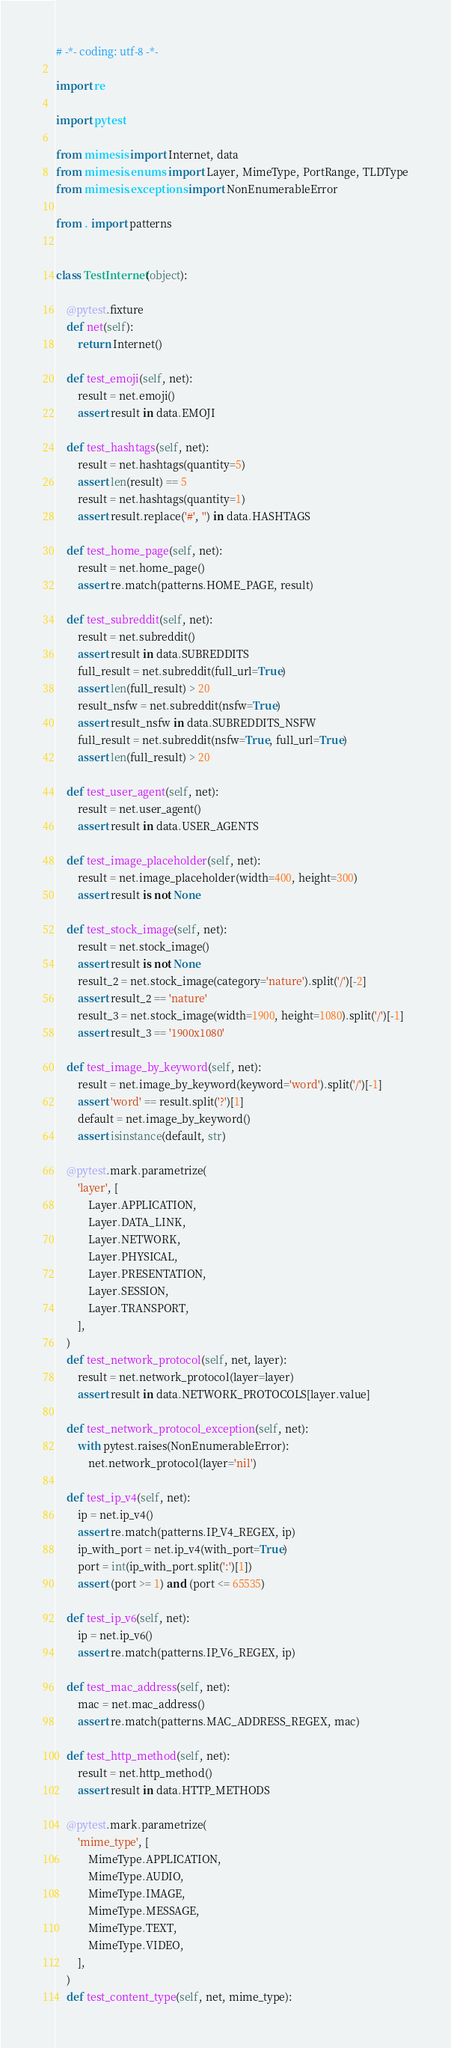<code> <loc_0><loc_0><loc_500><loc_500><_Python_># -*- coding: utf-8 -*-

import re

import pytest

from mimesis import Internet, data
from mimesis.enums import Layer, MimeType, PortRange, TLDType
from mimesis.exceptions import NonEnumerableError

from . import patterns


class TestInternet(object):

    @pytest.fixture
    def net(self):
        return Internet()

    def test_emoji(self, net):
        result = net.emoji()
        assert result in data.EMOJI

    def test_hashtags(self, net):
        result = net.hashtags(quantity=5)
        assert len(result) == 5
        result = net.hashtags(quantity=1)
        assert result.replace('#', '') in data.HASHTAGS

    def test_home_page(self, net):
        result = net.home_page()
        assert re.match(patterns.HOME_PAGE, result)

    def test_subreddit(self, net):
        result = net.subreddit()
        assert result in data.SUBREDDITS
        full_result = net.subreddit(full_url=True)
        assert len(full_result) > 20
        result_nsfw = net.subreddit(nsfw=True)
        assert result_nsfw in data.SUBREDDITS_NSFW
        full_result = net.subreddit(nsfw=True, full_url=True)
        assert len(full_result) > 20

    def test_user_agent(self, net):
        result = net.user_agent()
        assert result in data.USER_AGENTS

    def test_image_placeholder(self, net):
        result = net.image_placeholder(width=400, height=300)
        assert result is not None

    def test_stock_image(self, net):
        result = net.stock_image()
        assert result is not None
        result_2 = net.stock_image(category='nature').split('/')[-2]
        assert result_2 == 'nature'
        result_3 = net.stock_image(width=1900, height=1080).split('/')[-1]
        assert result_3 == '1900x1080'

    def test_image_by_keyword(self, net):
        result = net.image_by_keyword(keyword='word').split('/')[-1]
        assert 'word' == result.split('?')[1]
        default = net.image_by_keyword()
        assert isinstance(default, str)

    @pytest.mark.parametrize(
        'layer', [
            Layer.APPLICATION,
            Layer.DATA_LINK,
            Layer.NETWORK,
            Layer.PHYSICAL,
            Layer.PRESENTATION,
            Layer.SESSION,
            Layer.TRANSPORT,
        ],
    )
    def test_network_protocol(self, net, layer):
        result = net.network_protocol(layer=layer)
        assert result in data.NETWORK_PROTOCOLS[layer.value]

    def test_network_protocol_exception(self, net):
        with pytest.raises(NonEnumerableError):
            net.network_protocol(layer='nil')

    def test_ip_v4(self, net):
        ip = net.ip_v4()
        assert re.match(patterns.IP_V4_REGEX, ip)
        ip_with_port = net.ip_v4(with_port=True)
        port = int(ip_with_port.split(':')[1])
        assert (port >= 1) and (port <= 65535)

    def test_ip_v6(self, net):
        ip = net.ip_v6()
        assert re.match(patterns.IP_V6_REGEX, ip)

    def test_mac_address(self, net):
        mac = net.mac_address()
        assert re.match(patterns.MAC_ADDRESS_REGEX, mac)

    def test_http_method(self, net):
        result = net.http_method()
        assert result in data.HTTP_METHODS

    @pytest.mark.parametrize(
        'mime_type', [
            MimeType.APPLICATION,
            MimeType.AUDIO,
            MimeType.IMAGE,
            MimeType.MESSAGE,
            MimeType.TEXT,
            MimeType.VIDEO,
        ],
    )
    def test_content_type(self, net, mime_type):</code> 